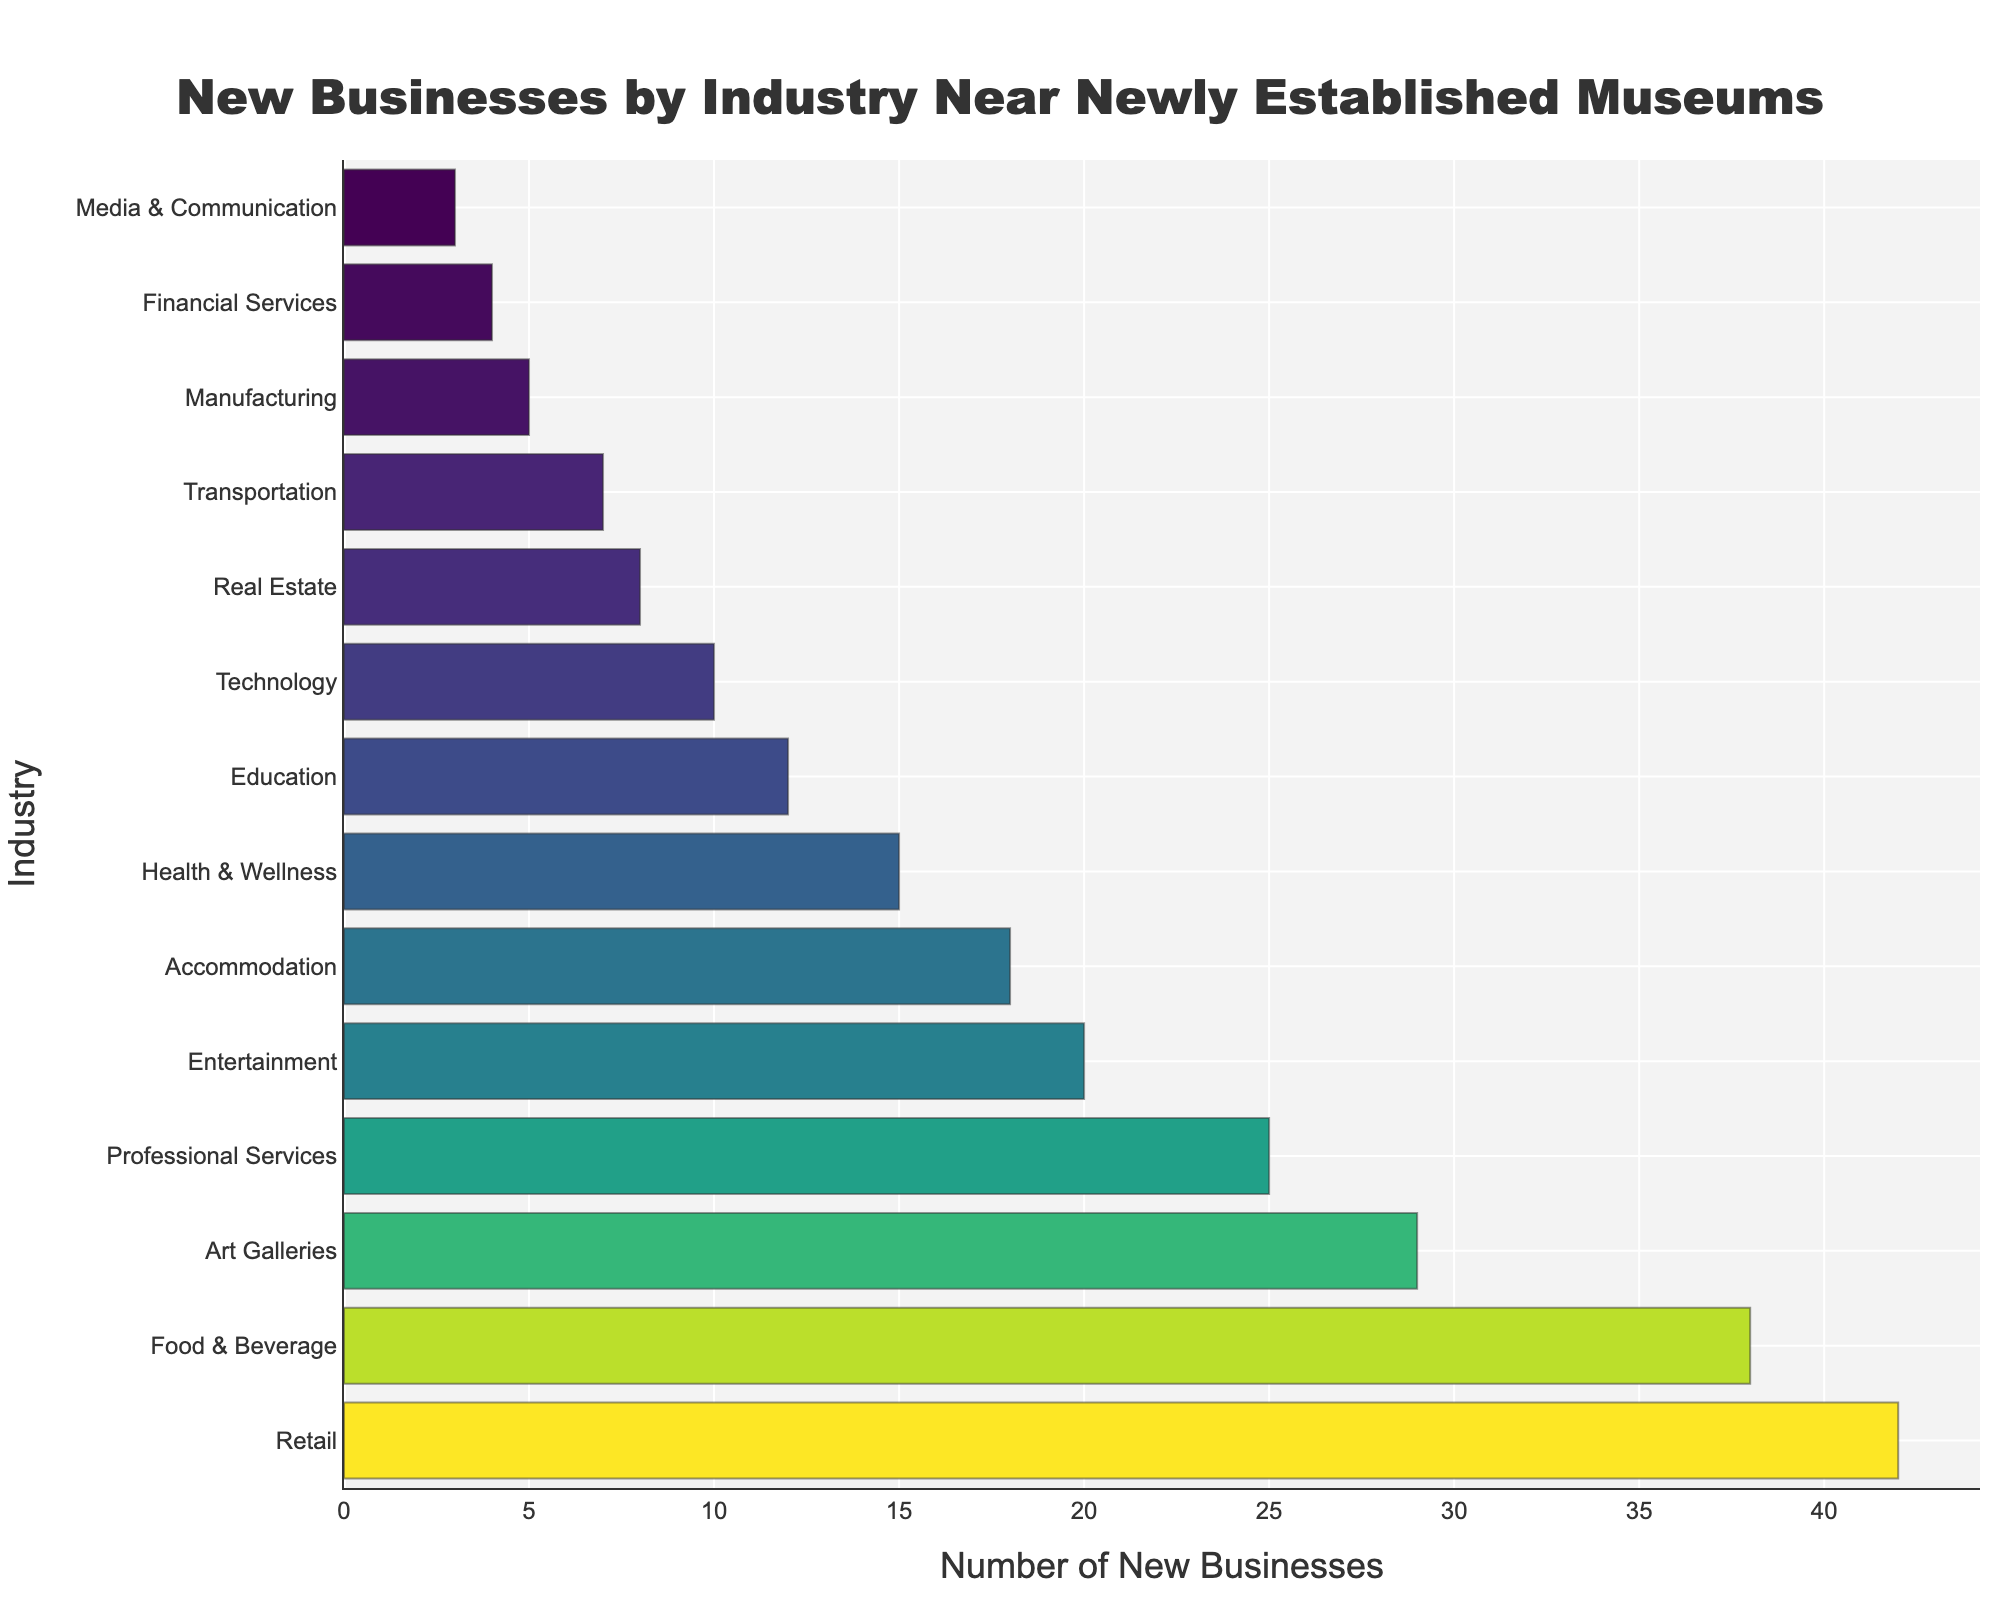Which industry has the highest number of new businesses opened near newly established museums? The bar representing 'Retail' is the longest bar in the chart, indicating it has the highest number of new businesses.
Answer: Retail How many more new businesses are there in Food & Beverage compared to Technology? The bar for Food & Beverage is at 38, and the bar for Technology is at 10. The difference is calculated as 38 - 10.
Answer: 28 What is the total number of new businesses in the top three industries? The number of new businesses in the top three industries (Retail, Food & Beverage, and Art Galleries) are 42, 38, and 29 respectively. The total is 42 + 38 + 29.
Answer: 109 Which two industries have the smallest number of new businesses? The shortest bars in the chart represent 'Media & Communication' with 3 new businesses and 'Financial Services' with 4 new businesses.
Answer: Media & Communication and Financial Services What is the median number of new businesses opened across all industries? First, list all the numbers of new businesses: [3, 4, 5, 7, 8, 10, 12, 15, 18, 20, 25, 29, 38, 42]. Since there are 14 data points (even number), the median is the average of the 7th and 8th numbers. Median = (12 + 15) / 2.
Answer: 13.5 Which industry shows the closest number of new businesses to the median value? From the list: [3, 4, 5, 7, 8, 10, 12, 15, 18, 20, 25, 29, 38, 42], the closest number to the median value of 13.5 is 'Health & Wellness' with 15.
Answer: Health & Wellness Are there more new businesses in Professional Services or Entertainment? The bar for Professional Services reaches 25, while the bar for Entertainment reaches 20. Comparing these values, Professional Services has more new businesses.
Answer: Professional Services How many industries have at least 20 new businesses opened? The bars that reach or exceed 20 are for the industries: Retail, Food & Beverage, Art Galleries, Professional Services, Entertainment, and Accommodation. Count = 6.
Answer: 6 